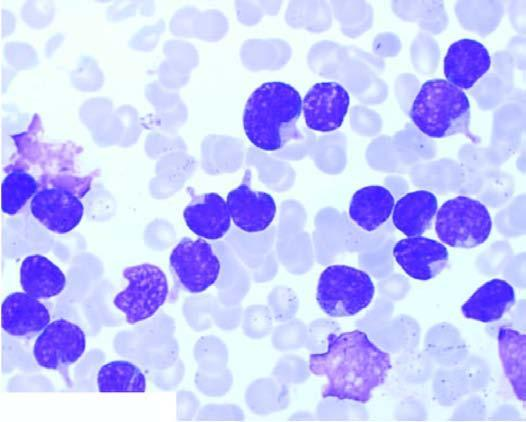what are large, with round to convoluted nuclei having high n/c ratio and no cytoplasmic granularity?
Answer the question using a single word or phrase. The cells 